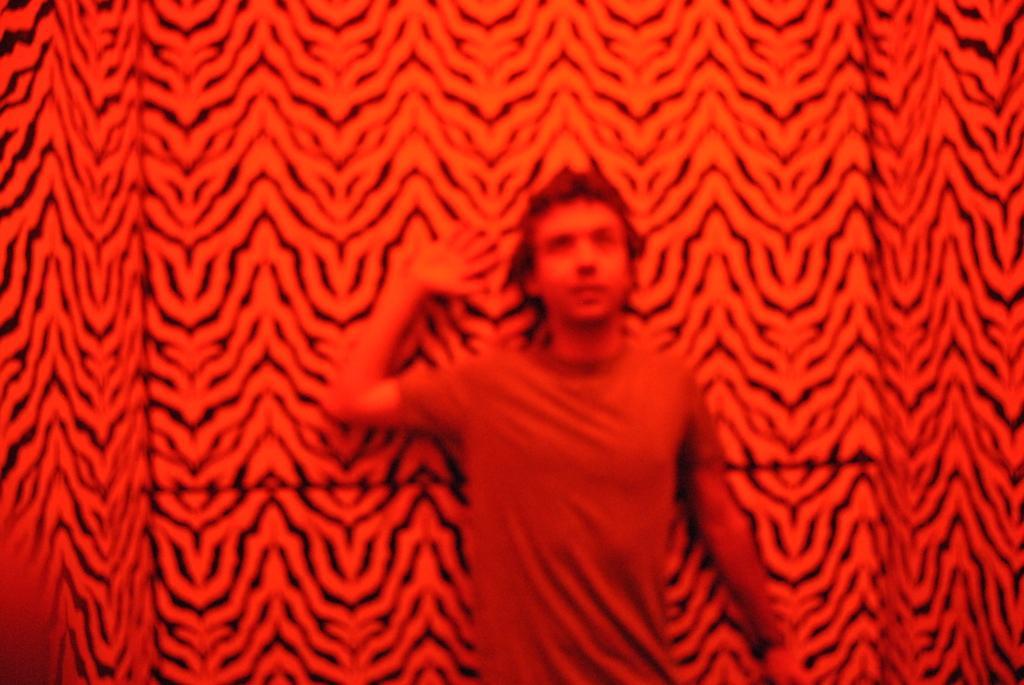How would you summarize this image in a sentence or two? I see this image is red in color and I see a man over here who is wearing t-shirt and I see the wall which is of red and black in color. 